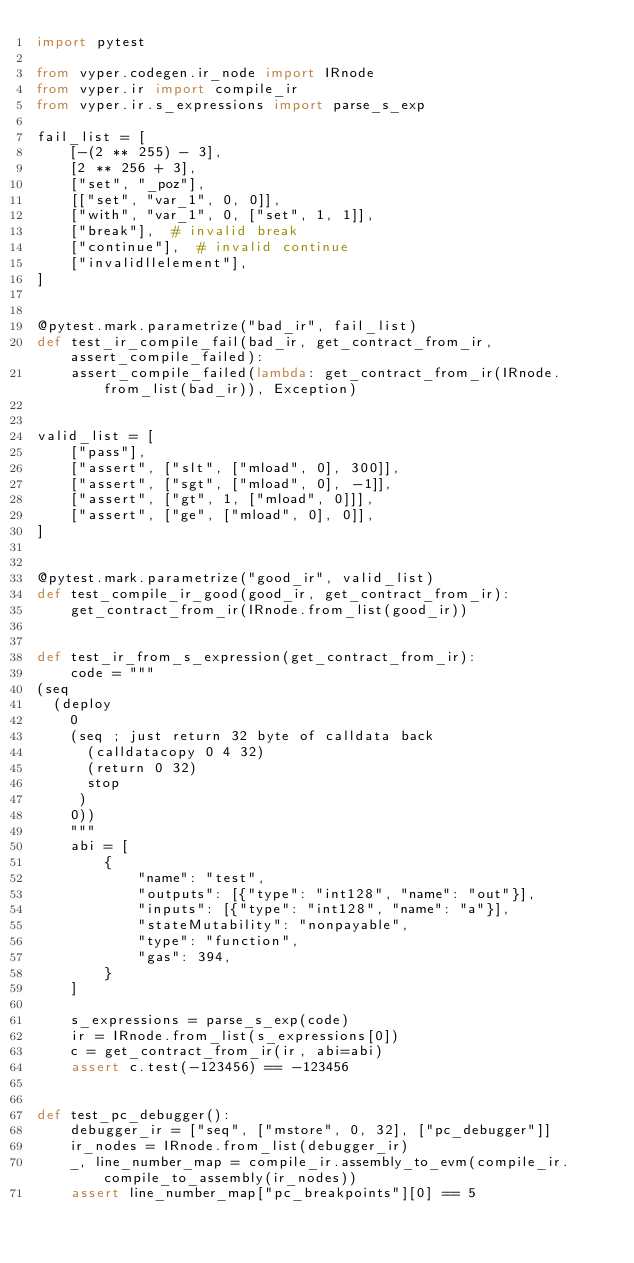<code> <loc_0><loc_0><loc_500><loc_500><_Python_>import pytest

from vyper.codegen.ir_node import IRnode
from vyper.ir import compile_ir
from vyper.ir.s_expressions import parse_s_exp

fail_list = [
    [-(2 ** 255) - 3],
    [2 ** 256 + 3],
    ["set", "_poz"],
    [["set", "var_1", 0, 0]],
    ["with", "var_1", 0, ["set", 1, 1]],
    ["break"],  # invalid break
    ["continue"],  # invalid continue
    ["invalidllelement"],
]


@pytest.mark.parametrize("bad_ir", fail_list)
def test_ir_compile_fail(bad_ir, get_contract_from_ir, assert_compile_failed):
    assert_compile_failed(lambda: get_contract_from_ir(IRnode.from_list(bad_ir)), Exception)


valid_list = [
    ["pass"],
    ["assert", ["slt", ["mload", 0], 300]],
    ["assert", ["sgt", ["mload", 0], -1]],
    ["assert", ["gt", 1, ["mload", 0]]],
    ["assert", ["ge", ["mload", 0], 0]],
]


@pytest.mark.parametrize("good_ir", valid_list)
def test_compile_ir_good(good_ir, get_contract_from_ir):
    get_contract_from_ir(IRnode.from_list(good_ir))


def test_ir_from_s_expression(get_contract_from_ir):
    code = """
(seq
  (deploy
    0
    (seq ; just return 32 byte of calldata back
      (calldatacopy 0 4 32)
      (return 0 32)
      stop
     )
    0))
    """
    abi = [
        {
            "name": "test",
            "outputs": [{"type": "int128", "name": "out"}],
            "inputs": [{"type": "int128", "name": "a"}],
            "stateMutability": "nonpayable",
            "type": "function",
            "gas": 394,
        }
    ]

    s_expressions = parse_s_exp(code)
    ir = IRnode.from_list(s_expressions[0])
    c = get_contract_from_ir(ir, abi=abi)
    assert c.test(-123456) == -123456


def test_pc_debugger():
    debugger_ir = ["seq", ["mstore", 0, 32], ["pc_debugger"]]
    ir_nodes = IRnode.from_list(debugger_ir)
    _, line_number_map = compile_ir.assembly_to_evm(compile_ir.compile_to_assembly(ir_nodes))
    assert line_number_map["pc_breakpoints"][0] == 5
</code> 